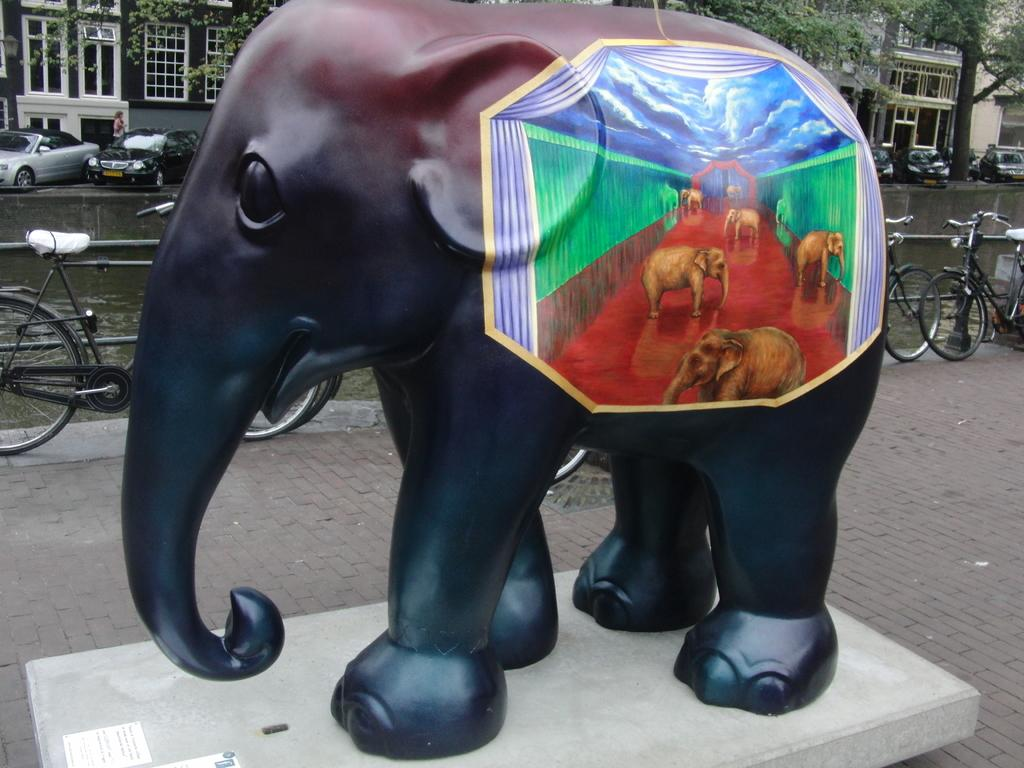What is the main subject of the image? There is an elephant statue in the image. What can be seen in the background of the image? In the background, there are bicycles, fencing, a lake, a road with cars, trees, and buildings. Can you describe the landscape in the image? The landscape includes a lake, trees, and buildings in the background, with a road beside the lake. Are there any vehicles visible in the image? Yes, there are cars on the road in the background. What type of current can be seen flowing through the lake in the image? A: There is no current visible in the lake in the image. How many cows are present in the image? There are no cows present in the image. 